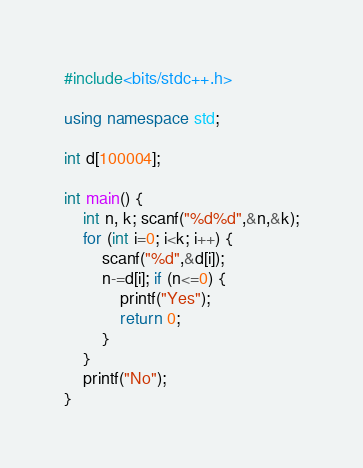<code> <loc_0><loc_0><loc_500><loc_500><_C++_>#include<bits/stdc++.h>

using namespace std;

int d[100004];

int main() {
    int n, k; scanf("%d%d",&n,&k);
    for (int i=0; i<k; i++) {
        scanf("%d",&d[i]);
        n-=d[i]; if (n<=0) {
            printf("Yes");
            return 0;
        }
    }
    printf("No");
}</code> 